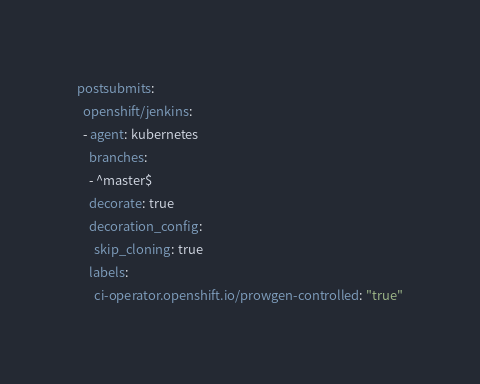Convert code to text. <code><loc_0><loc_0><loc_500><loc_500><_YAML_>postsubmits:
  openshift/jenkins:
  - agent: kubernetes
    branches:
    - ^master$
    decorate: true
    decoration_config:
      skip_cloning: true
    labels:
      ci-operator.openshift.io/prowgen-controlled: "true"</code> 